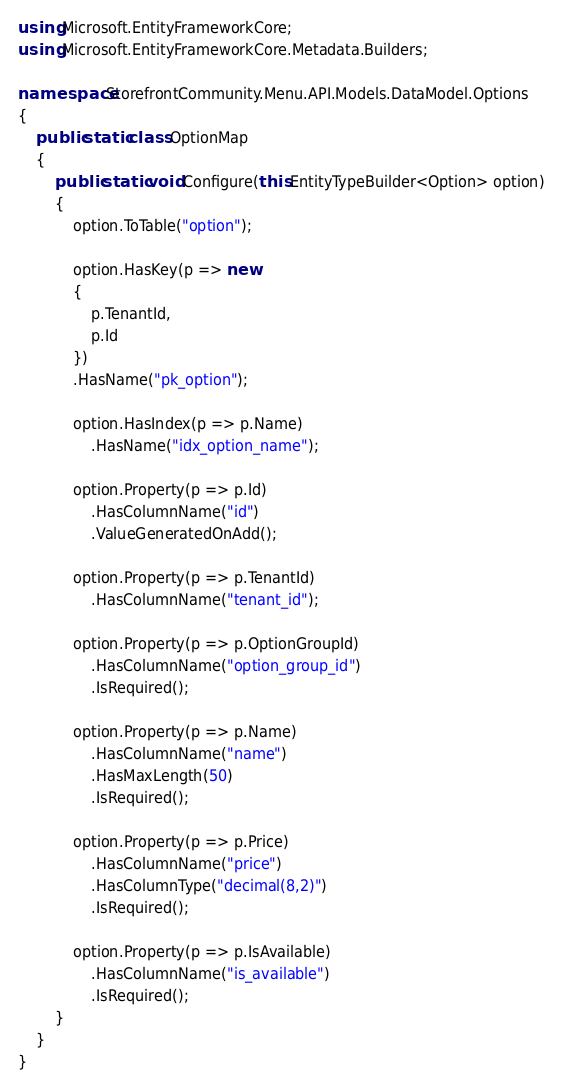Convert code to text. <code><loc_0><loc_0><loc_500><loc_500><_C#_>using Microsoft.EntityFrameworkCore;
using Microsoft.EntityFrameworkCore.Metadata.Builders;

namespace StorefrontCommunity.Menu.API.Models.DataModel.Options
{
    public static class OptionMap
    {
        public static void Configure(this EntityTypeBuilder<Option> option)
        {
            option.ToTable("option");

            option.HasKey(p => new
            {
                p.TenantId,
                p.Id
            })
            .HasName("pk_option");

            option.HasIndex(p => p.Name)
                .HasName("idx_option_name");

            option.Property(p => p.Id)
                .HasColumnName("id")
                .ValueGeneratedOnAdd();

            option.Property(p => p.TenantId)
                .HasColumnName("tenant_id");

            option.Property(p => p.OptionGroupId)
                .HasColumnName("option_group_id")
                .IsRequired();

            option.Property(p => p.Name)
                .HasColumnName("name")
                .HasMaxLength(50)
                .IsRequired();

            option.Property(p => p.Price)
                .HasColumnName("price")
                .HasColumnType("decimal(8,2)")
                .IsRequired();

            option.Property(p => p.IsAvailable)
                .HasColumnName("is_available")
                .IsRequired();
        }
    }
}
</code> 